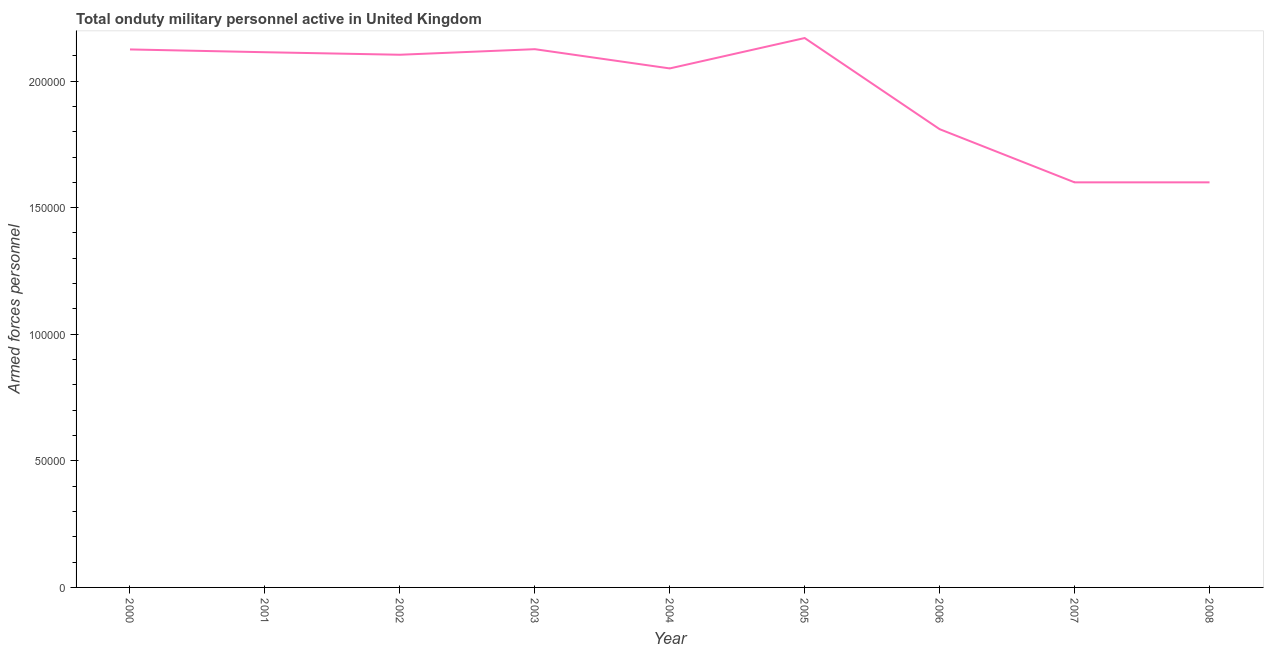What is the number of armed forces personnel in 2003?
Offer a very short reply. 2.13e+05. Across all years, what is the maximum number of armed forces personnel?
Give a very brief answer. 2.17e+05. Across all years, what is the minimum number of armed forces personnel?
Your response must be concise. 1.60e+05. In which year was the number of armed forces personnel minimum?
Your answer should be very brief. 2007. What is the sum of the number of armed forces personnel?
Keep it short and to the point. 1.77e+06. What is the difference between the number of armed forces personnel in 2002 and 2003?
Provide a short and direct response. -2200. What is the average number of armed forces personnel per year?
Your answer should be compact. 1.97e+05. What is the median number of armed forces personnel?
Your answer should be compact. 2.10e+05. In how many years, is the number of armed forces personnel greater than 100000 ?
Your answer should be very brief. 9. What is the ratio of the number of armed forces personnel in 2006 to that in 2008?
Offer a terse response. 1.13. Is the number of armed forces personnel in 2003 less than that in 2006?
Give a very brief answer. No. Is the difference between the number of armed forces personnel in 2007 and 2008 greater than the difference between any two years?
Your answer should be compact. No. What is the difference between the highest and the second highest number of armed forces personnel?
Provide a succinct answer. 4400. What is the difference between the highest and the lowest number of armed forces personnel?
Keep it short and to the point. 5.70e+04. Does the number of armed forces personnel monotonically increase over the years?
Your answer should be compact. No. How many lines are there?
Ensure brevity in your answer.  1. How many years are there in the graph?
Your answer should be very brief. 9. Are the values on the major ticks of Y-axis written in scientific E-notation?
Provide a succinct answer. No. Does the graph contain grids?
Provide a succinct answer. No. What is the title of the graph?
Provide a short and direct response. Total onduty military personnel active in United Kingdom. What is the label or title of the Y-axis?
Provide a succinct answer. Armed forces personnel. What is the Armed forces personnel in 2000?
Your response must be concise. 2.12e+05. What is the Armed forces personnel in 2001?
Your response must be concise. 2.11e+05. What is the Armed forces personnel in 2002?
Your answer should be very brief. 2.10e+05. What is the Armed forces personnel in 2003?
Make the answer very short. 2.13e+05. What is the Armed forces personnel in 2004?
Ensure brevity in your answer.  2.05e+05. What is the Armed forces personnel of 2005?
Your answer should be compact. 2.17e+05. What is the Armed forces personnel of 2006?
Give a very brief answer. 1.81e+05. What is the Armed forces personnel of 2007?
Keep it short and to the point. 1.60e+05. What is the difference between the Armed forces personnel in 2000 and 2001?
Keep it short and to the point. 1100. What is the difference between the Armed forces personnel in 2000 and 2002?
Provide a succinct answer. 2100. What is the difference between the Armed forces personnel in 2000 and 2003?
Keep it short and to the point. -100. What is the difference between the Armed forces personnel in 2000 and 2004?
Make the answer very short. 7500. What is the difference between the Armed forces personnel in 2000 and 2005?
Ensure brevity in your answer.  -4500. What is the difference between the Armed forces personnel in 2000 and 2006?
Keep it short and to the point. 3.15e+04. What is the difference between the Armed forces personnel in 2000 and 2007?
Make the answer very short. 5.25e+04. What is the difference between the Armed forces personnel in 2000 and 2008?
Give a very brief answer. 5.25e+04. What is the difference between the Armed forces personnel in 2001 and 2003?
Your answer should be very brief. -1200. What is the difference between the Armed forces personnel in 2001 and 2004?
Ensure brevity in your answer.  6400. What is the difference between the Armed forces personnel in 2001 and 2005?
Provide a short and direct response. -5600. What is the difference between the Armed forces personnel in 2001 and 2006?
Make the answer very short. 3.04e+04. What is the difference between the Armed forces personnel in 2001 and 2007?
Make the answer very short. 5.14e+04. What is the difference between the Armed forces personnel in 2001 and 2008?
Offer a very short reply. 5.14e+04. What is the difference between the Armed forces personnel in 2002 and 2003?
Make the answer very short. -2200. What is the difference between the Armed forces personnel in 2002 and 2004?
Give a very brief answer. 5400. What is the difference between the Armed forces personnel in 2002 and 2005?
Provide a short and direct response. -6600. What is the difference between the Armed forces personnel in 2002 and 2006?
Offer a terse response. 2.94e+04. What is the difference between the Armed forces personnel in 2002 and 2007?
Keep it short and to the point. 5.04e+04. What is the difference between the Armed forces personnel in 2002 and 2008?
Offer a very short reply. 5.04e+04. What is the difference between the Armed forces personnel in 2003 and 2004?
Your answer should be compact. 7600. What is the difference between the Armed forces personnel in 2003 and 2005?
Make the answer very short. -4400. What is the difference between the Armed forces personnel in 2003 and 2006?
Ensure brevity in your answer.  3.16e+04. What is the difference between the Armed forces personnel in 2003 and 2007?
Your response must be concise. 5.26e+04. What is the difference between the Armed forces personnel in 2003 and 2008?
Give a very brief answer. 5.26e+04. What is the difference between the Armed forces personnel in 2004 and 2005?
Ensure brevity in your answer.  -1.20e+04. What is the difference between the Armed forces personnel in 2004 and 2006?
Make the answer very short. 2.40e+04. What is the difference between the Armed forces personnel in 2004 and 2007?
Your response must be concise. 4.50e+04. What is the difference between the Armed forces personnel in 2004 and 2008?
Your answer should be very brief. 4.50e+04. What is the difference between the Armed forces personnel in 2005 and 2006?
Provide a short and direct response. 3.60e+04. What is the difference between the Armed forces personnel in 2005 and 2007?
Provide a succinct answer. 5.70e+04. What is the difference between the Armed forces personnel in 2005 and 2008?
Ensure brevity in your answer.  5.70e+04. What is the difference between the Armed forces personnel in 2006 and 2007?
Offer a terse response. 2.10e+04. What is the difference between the Armed forces personnel in 2006 and 2008?
Keep it short and to the point. 2.10e+04. What is the difference between the Armed forces personnel in 2007 and 2008?
Your answer should be compact. 0. What is the ratio of the Armed forces personnel in 2000 to that in 2002?
Keep it short and to the point. 1.01. What is the ratio of the Armed forces personnel in 2000 to that in 2003?
Keep it short and to the point. 1. What is the ratio of the Armed forces personnel in 2000 to that in 2006?
Offer a very short reply. 1.17. What is the ratio of the Armed forces personnel in 2000 to that in 2007?
Your answer should be very brief. 1.33. What is the ratio of the Armed forces personnel in 2000 to that in 2008?
Offer a very short reply. 1.33. What is the ratio of the Armed forces personnel in 2001 to that in 2003?
Ensure brevity in your answer.  0.99. What is the ratio of the Armed forces personnel in 2001 to that in 2004?
Give a very brief answer. 1.03. What is the ratio of the Armed forces personnel in 2001 to that in 2005?
Your answer should be compact. 0.97. What is the ratio of the Armed forces personnel in 2001 to that in 2006?
Offer a terse response. 1.17. What is the ratio of the Armed forces personnel in 2001 to that in 2007?
Your answer should be very brief. 1.32. What is the ratio of the Armed forces personnel in 2001 to that in 2008?
Your answer should be compact. 1.32. What is the ratio of the Armed forces personnel in 2002 to that in 2003?
Keep it short and to the point. 0.99. What is the ratio of the Armed forces personnel in 2002 to that in 2004?
Give a very brief answer. 1.03. What is the ratio of the Armed forces personnel in 2002 to that in 2005?
Give a very brief answer. 0.97. What is the ratio of the Armed forces personnel in 2002 to that in 2006?
Make the answer very short. 1.16. What is the ratio of the Armed forces personnel in 2002 to that in 2007?
Provide a short and direct response. 1.31. What is the ratio of the Armed forces personnel in 2002 to that in 2008?
Provide a succinct answer. 1.31. What is the ratio of the Armed forces personnel in 2003 to that in 2004?
Give a very brief answer. 1.04. What is the ratio of the Armed forces personnel in 2003 to that in 2005?
Your answer should be very brief. 0.98. What is the ratio of the Armed forces personnel in 2003 to that in 2006?
Make the answer very short. 1.18. What is the ratio of the Armed forces personnel in 2003 to that in 2007?
Your answer should be compact. 1.33. What is the ratio of the Armed forces personnel in 2003 to that in 2008?
Ensure brevity in your answer.  1.33. What is the ratio of the Armed forces personnel in 2004 to that in 2005?
Ensure brevity in your answer.  0.94. What is the ratio of the Armed forces personnel in 2004 to that in 2006?
Your response must be concise. 1.13. What is the ratio of the Armed forces personnel in 2004 to that in 2007?
Offer a terse response. 1.28. What is the ratio of the Armed forces personnel in 2004 to that in 2008?
Provide a succinct answer. 1.28. What is the ratio of the Armed forces personnel in 2005 to that in 2006?
Keep it short and to the point. 1.2. What is the ratio of the Armed forces personnel in 2005 to that in 2007?
Make the answer very short. 1.36. What is the ratio of the Armed forces personnel in 2005 to that in 2008?
Give a very brief answer. 1.36. What is the ratio of the Armed forces personnel in 2006 to that in 2007?
Your answer should be compact. 1.13. What is the ratio of the Armed forces personnel in 2006 to that in 2008?
Offer a terse response. 1.13. 